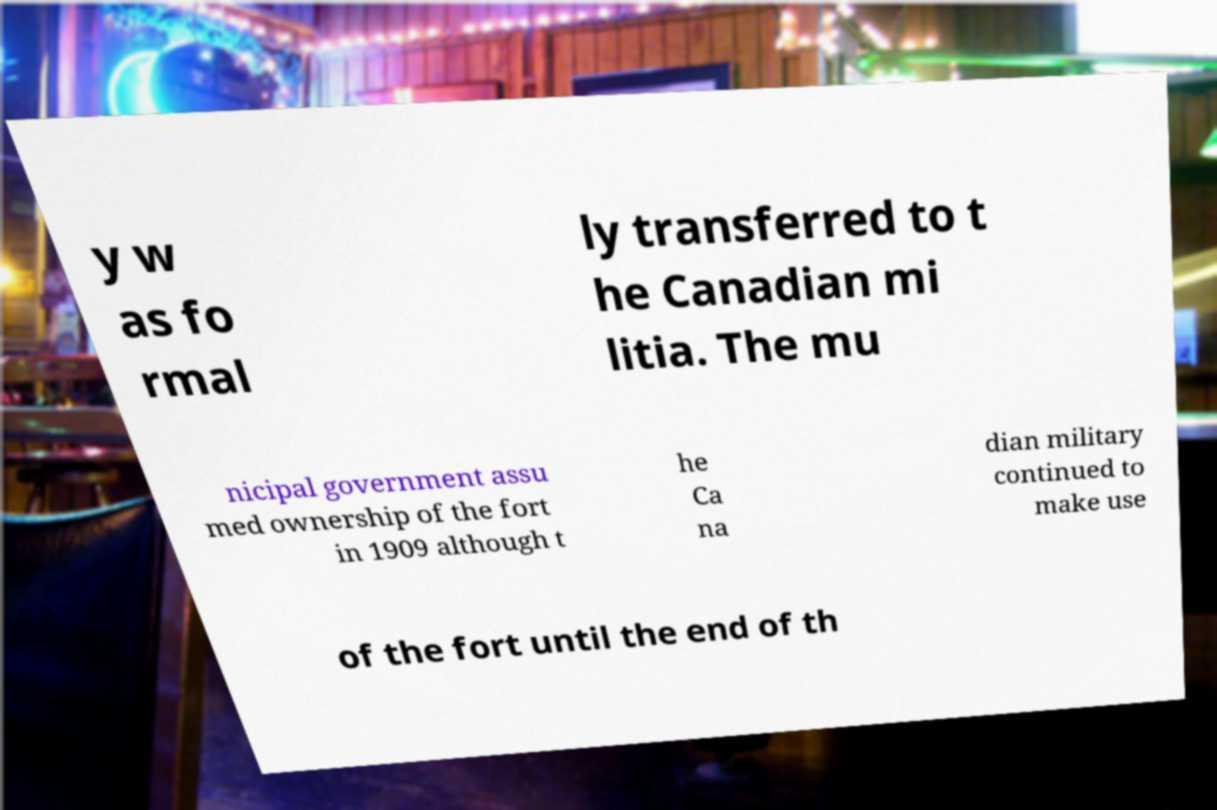What messages or text are displayed in this image? I need them in a readable, typed format. y w as fo rmal ly transferred to t he Canadian mi litia. The mu nicipal government assu med ownership of the fort in 1909 although t he Ca na dian military continued to make use of the fort until the end of th 